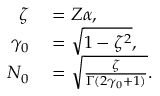<formula> <loc_0><loc_0><loc_500><loc_500>\begin{array} { r l } { \zeta } & = Z \alpha , } \\ { \gamma _ { 0 } } & = \sqrt { 1 - \zeta ^ { 2 } } , } \\ { N _ { 0 } } & = \sqrt { \frac { \zeta } { \Gamma ( 2 \gamma _ { 0 } + 1 ) } } . } \end{array}</formula> 